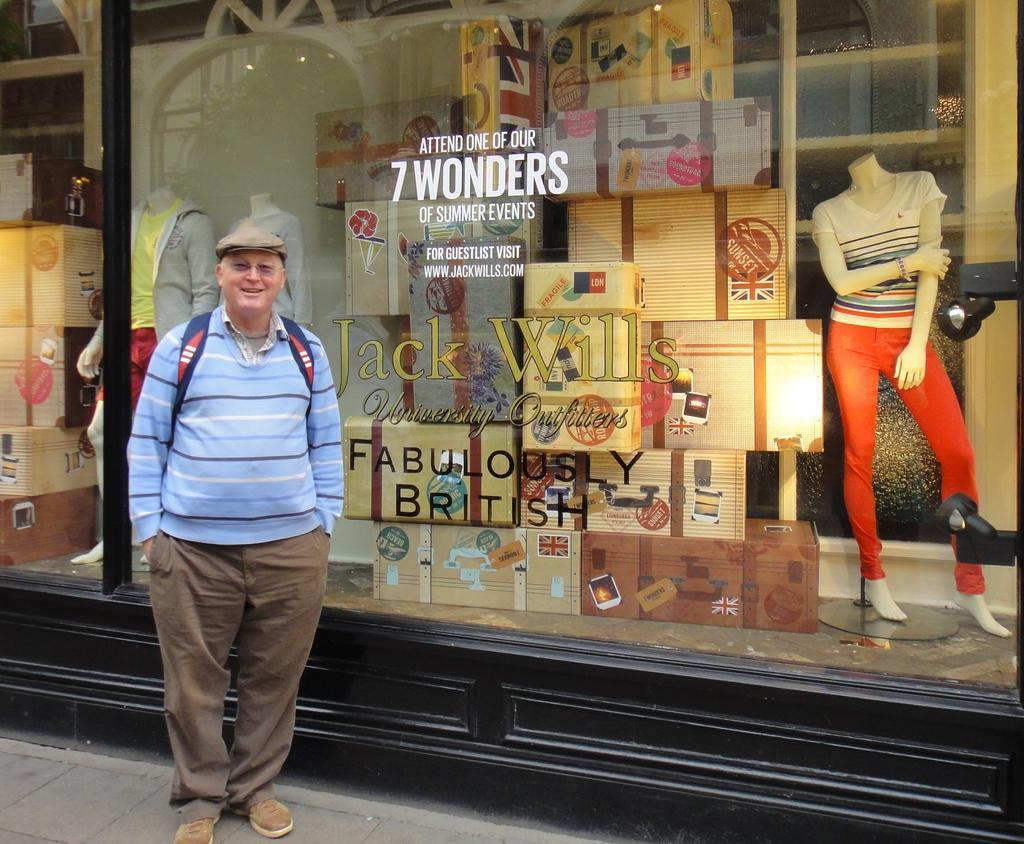How would you summarize this image in a sentence or two? In this picture we can see a man standing and smiling, in the background there is a glass, from the glass we can see mannequins and some boxes, there is some text on the glass. 